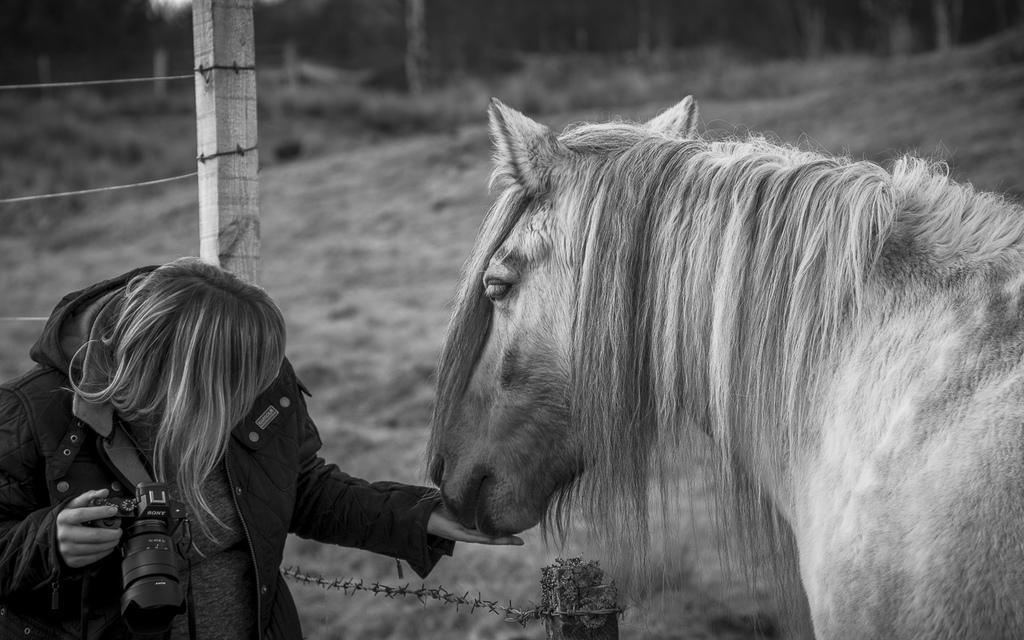How would you summarize this image in a sentence or two? In this image we can see a horse on right side and a woman holding a camera in her hands on the left side. In the background we can see fence. 